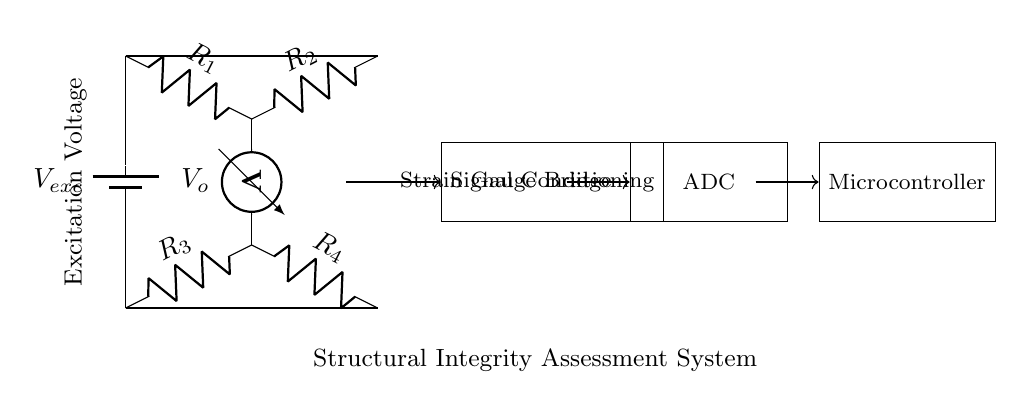What is the excitation voltage used in the circuit? The excitation voltage is provided from the battery labeled as Vexc. It is positioned at the top left of the diagram, from which the voltage flows into the circuit.
Answer: Vexc What are the resistances used in the bridge? The circuit has four resistors labeled R1, R2, R3, and R4. They are connected in a specific arrangement that defines the strain gauge bridge configuration.
Answer: R1, R2, R3, R4 Where is the output voltage measured in the circuit? The output voltage, labeled Vo, is measured between the points connected by the vertical dashed line, which is in the middle of the circuit between the resistors R1 and R2, and R3 and R4.
Answer: Vo What is the purpose of the signal conditioning block? The signal conditioning block is positioned just after the bridge circuit and is used to process the small output voltage Vo before sending it to the ADC. It helps to amplify and filter the signal for better accuracy.
Answer: Signal conditioning Which component digitizes the output voltage? The component that digitizes the output voltage Vo is the Analog to Digital Converter (ADC), which takes the analog signal and converts it into a digital signal for the microcontroller to process.
Answer: ADC Why is a microcontroller included in the circuit? The microcontroller is included in the circuit to receive the digital signal from the ADC and analyze it for structural integrity assessment. This allows for computations and alerts based on the input data.
Answer: Microcontroller What type of circuit is shown in the diagram? The diagram shows a strain gauge bridge circuit, which is specifically designed for measuring the deformation or strain on structures, such as aging buildings.
Answer: Strain gauge bridge 